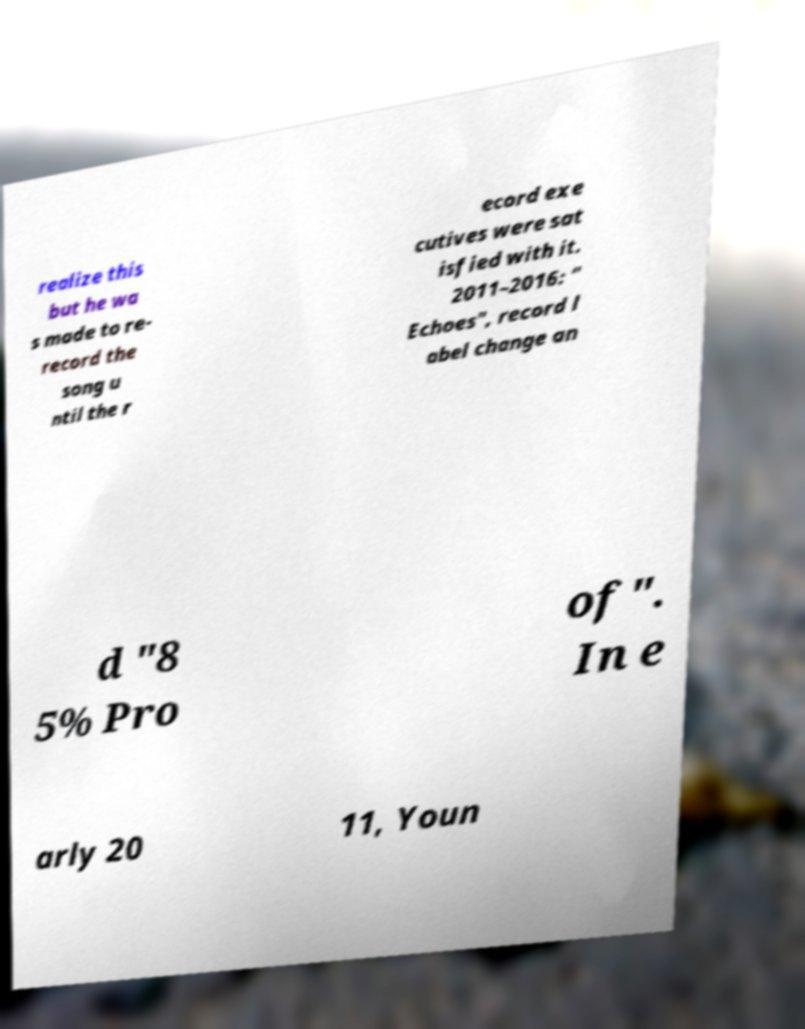Please read and relay the text visible in this image. What does it say? realize this but he wa s made to re- record the song u ntil the r ecord exe cutives were sat isfied with it. 2011–2016: " Echoes", record l abel change an d "8 5% Pro of". In e arly 20 11, Youn 